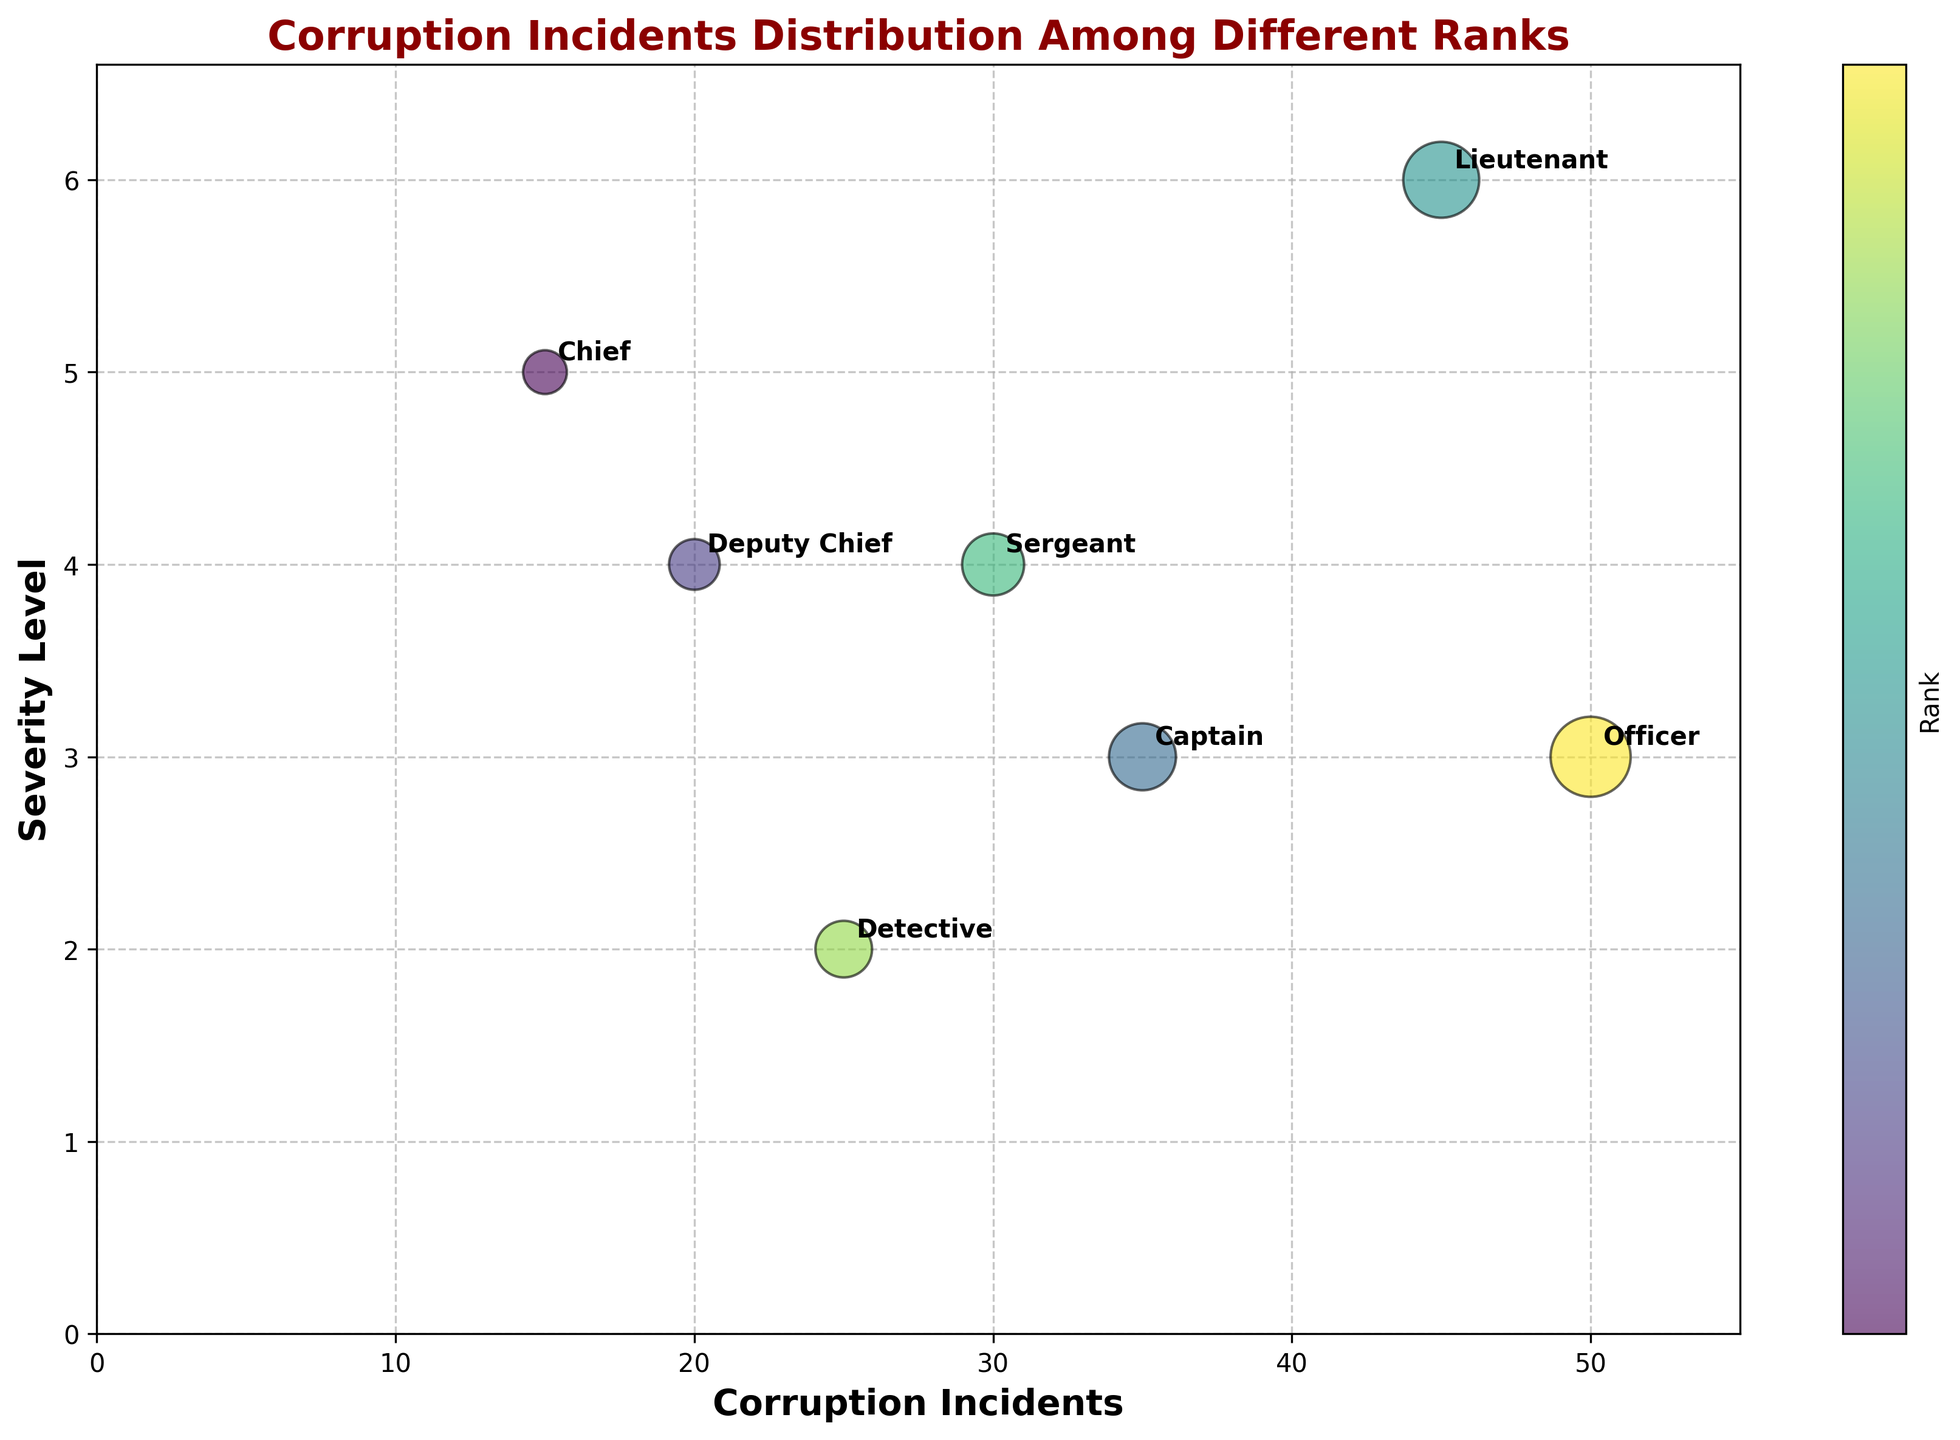What is the title of the figure? The title is usually located at the top of the figure and is in large, bold text. It provides an overview of the content. Here, the title is "Corruption Incidents Distribution Among Different Ranks".
Answer: Corruption Incidents Distribution Among Different Ranks How many different ranks are represented in the bubble chart? Count the number of distinct ranks annotated next to the bubbles. Each rank is labeled next to its corresponding bubble.
Answer: Seven Which rank has the highest number of corruption incidents? Look for the bubble with the highest x-coordinate, indicating the maximum number of corruption incidents. The corresponding rank is annotated next to this bubble.
Answer: Officer Which rank has the highest severity level? Look for the bubble with the highest y-coordinate, which represents the severity level. The corresponding rank is annotated next to this bubble.
Answer: Lieutenant What is the approximate size of the bubble representing the Chief? The size of each bubble is proportional to the number of corruption incidents. Locate the bubble labeled "Chief" and note its size relative to others. It is relatively small.
Answer: Small Which rank has the second-highest number of corruption incidents? First, identify the bubble with the highest x-coordinate (Officer). The second-highest bubble will have the next highest x-coordinate.
Answer: Lieutenant How does the severity level for Captains compare to that of Detectives? Find the y-coordinates of the bubbles labeled "Captain" and "Detective". The bubble with the higher y-coordinate has a higher severity level.
Answer: Captain's severity level is higher What is the average severity level of the ranks with more than 30 corruption incidents? Determine which ranks have more than 30 corruption incidents (Captain, Lieutenant, Officer). Find the severity levels for these ranks (3, 6, 3). Calculate the average: (3 + 6 + 3) / 3 = 4.
Answer: 4 Which ranks have an equal severity level, and what is that level? Find ranks that have identical y-coordinates, which represent the severity levels. For instance, ranks with severity level 4 might be highlighted.
Answer: Deputy Chief and Sergeant; Level 4 Is there a visible trend between the number of corruption incidents and severity level? Observe the spread and direction of the bubbles. If there's a discernible pattern (positive or negative), it indicates a trend.
Answer: No clear trend 